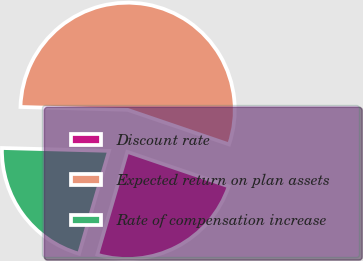<chart> <loc_0><loc_0><loc_500><loc_500><pie_chart><fcel>Discount rate<fcel>Expected return on plan assets<fcel>Rate of compensation increase<nl><fcel>24.29%<fcel>54.8%<fcel>20.91%<nl></chart> 